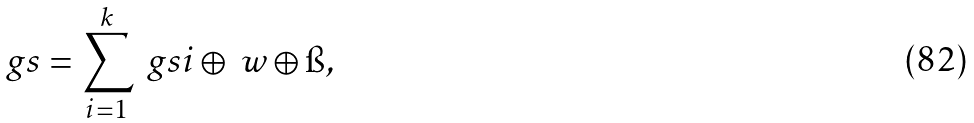Convert formula to latex. <formula><loc_0><loc_0><loc_500><loc_500>\ g s = \sum _ { i = 1 } ^ { k } \ g s i \oplus \ w \oplus \i ,</formula> 